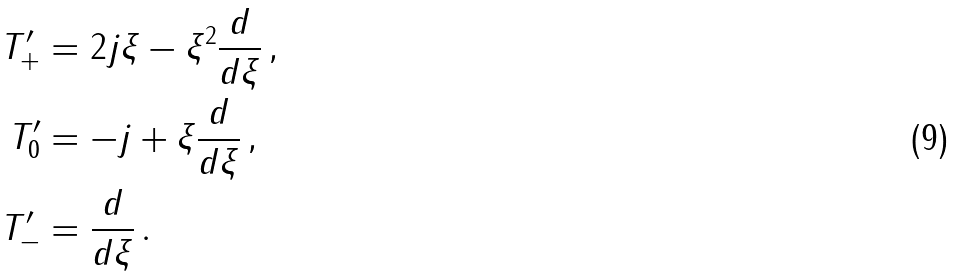<formula> <loc_0><loc_0><loc_500><loc_500>T _ { + } ^ { \prime } & = 2 j \xi - \xi ^ { 2 } \frac { d } { d \xi } \, , \\ T _ { 0 } ^ { \prime } & = - j + \xi \frac { d } { d \xi } \, , \\ T _ { - } ^ { \prime } & = \frac { d } { d \xi } \, .</formula> 